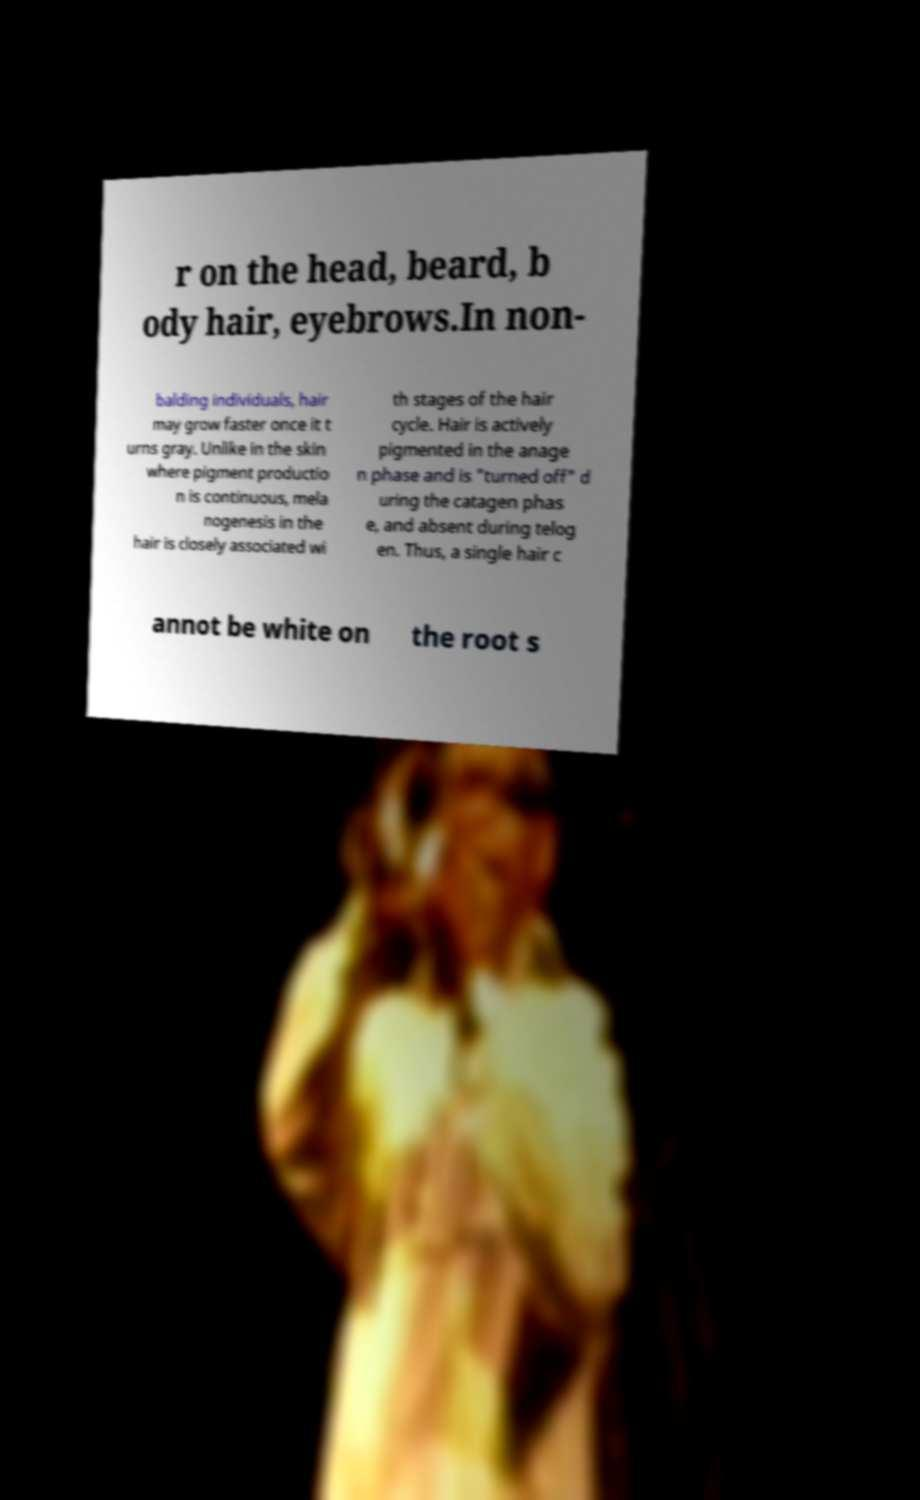Please identify and transcribe the text found in this image. r on the head, beard, b ody hair, eyebrows.In non- balding individuals, hair may grow faster once it t urns gray. Unlike in the skin where pigment productio n is continuous, mela nogenesis in the hair is closely associated wi th stages of the hair cycle. Hair is actively pigmented in the anage n phase and is "turned off" d uring the catagen phas e, and absent during telog en. Thus, a single hair c annot be white on the root s 